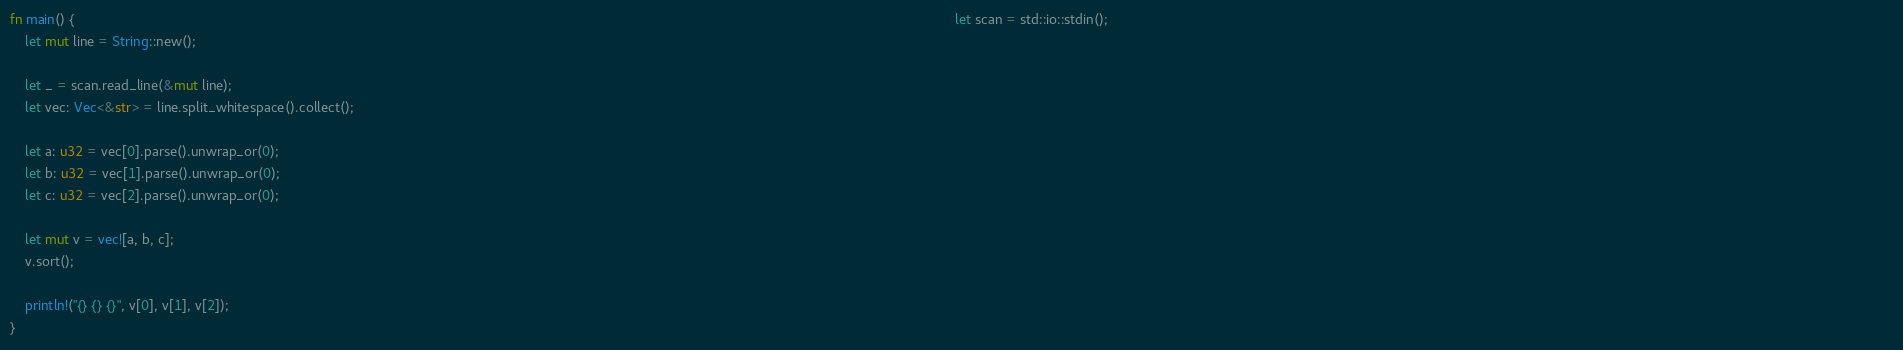Convert code to text. <code><loc_0><loc_0><loc_500><loc_500><_Rust_>fn main() {                                                                                                                                                                                                                                      let scan = std::io::stdin();                                                                                                                                                                                                             
    let mut line = String::new();

    let _ = scan.read_line(&mut line);
    let vec: Vec<&str> = line.split_whitespace().collect();

    let a: u32 = vec[0].parse().unwrap_or(0);
    let b: u32 = vec[1].parse().unwrap_or(0);
    let c: u32 = vec[2].parse().unwrap_or(0);

    let mut v = vec![a, b, c];
    v.sort();

    println!("{} {} {}", v[0], v[1], v[2]);
}
</code> 